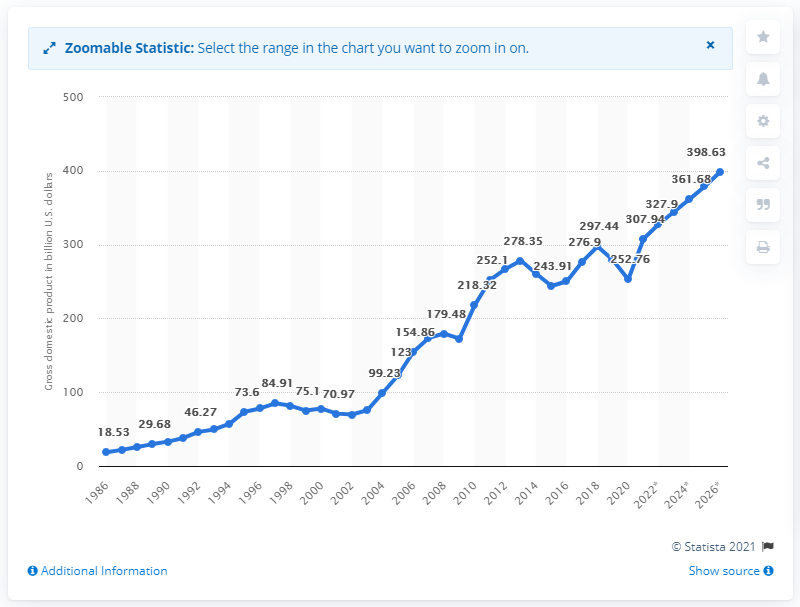Identify some key points in this picture. In 2020, Chile's gross domestic product was 252.76 billion dollars. 